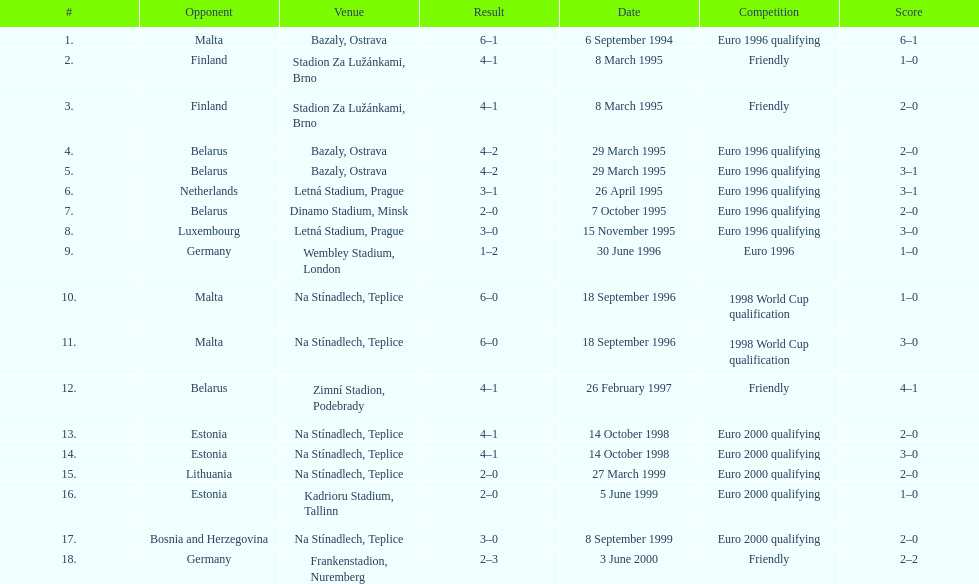Bazaly, ostrava was used on 6 september 1004, but what venue was used on 18 september 1996? Na Stínadlech, Teplice. 